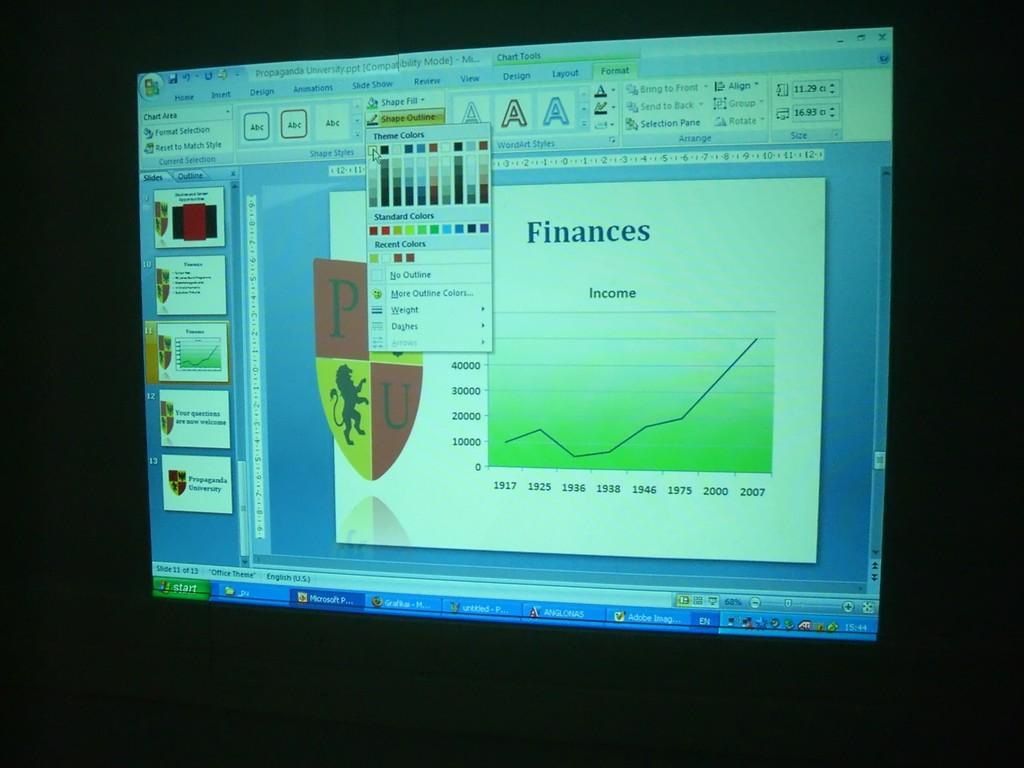<image>
Write a terse but informative summary of the picture. A screen with finances written on it and a chart 